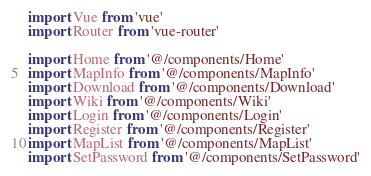<code> <loc_0><loc_0><loc_500><loc_500><_JavaScript_>import Vue from 'vue'
import Router from 'vue-router'

import Home from '@/components/Home'
import MapInfo from '@/components/MapInfo'
import Download from '@/components/Download'
import Wiki from '@/components/Wiki'
import Login from '@/components/Login'
import Register from '@/components/Register'
import MapList from '@/components/MapList'
import SetPassword from '@/components/SetPassword'</code> 